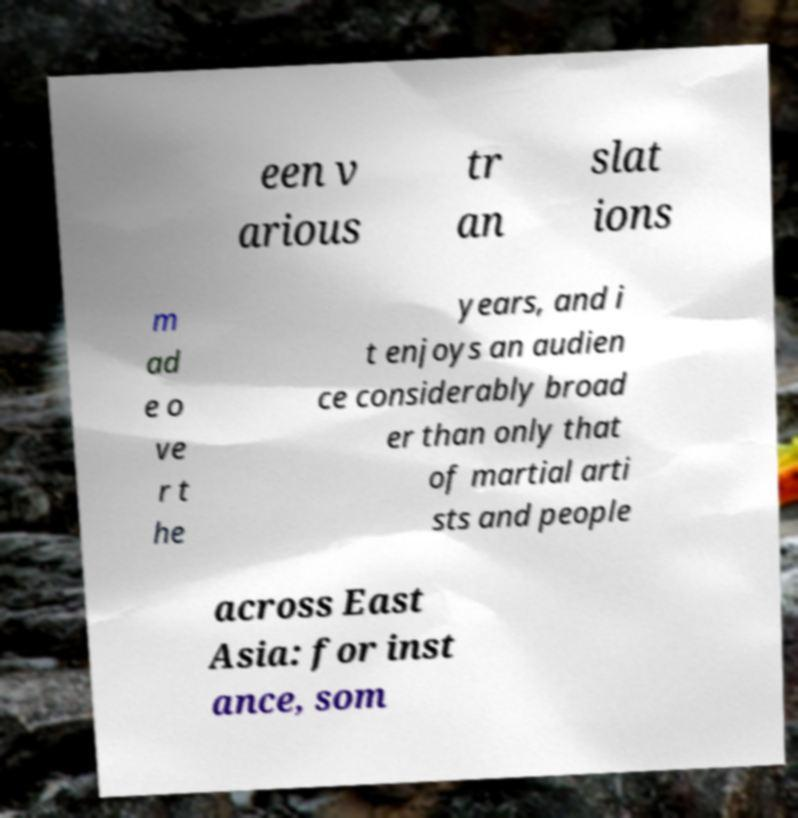I need the written content from this picture converted into text. Can you do that? een v arious tr an slat ions m ad e o ve r t he years, and i t enjoys an audien ce considerably broad er than only that of martial arti sts and people across East Asia: for inst ance, som 